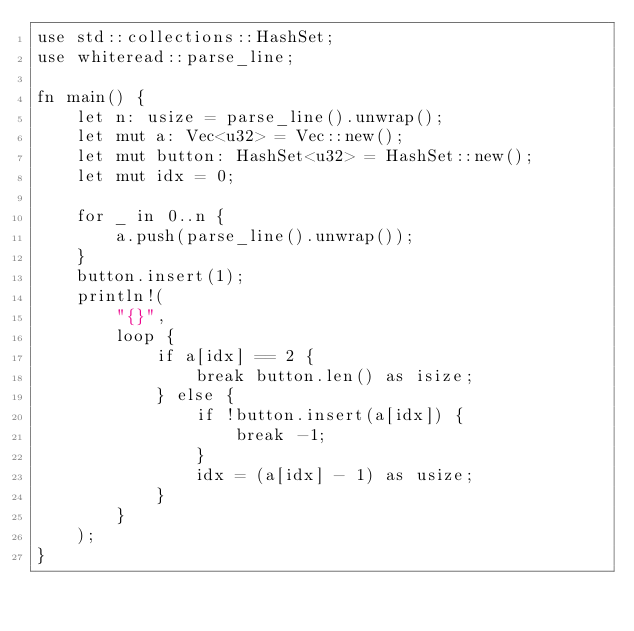<code> <loc_0><loc_0><loc_500><loc_500><_Rust_>use std::collections::HashSet;
use whiteread::parse_line;

fn main() {
    let n: usize = parse_line().unwrap();
    let mut a: Vec<u32> = Vec::new();
    let mut button: HashSet<u32> = HashSet::new();
    let mut idx = 0;

    for _ in 0..n {
        a.push(parse_line().unwrap());
    }
    button.insert(1);
    println!(
        "{}",
        loop {
            if a[idx] == 2 {
                break button.len() as isize;
            } else {
                if !button.insert(a[idx]) {
                    break -1;
                }
                idx = (a[idx] - 1) as usize;
            }
        }
    );
}
</code> 